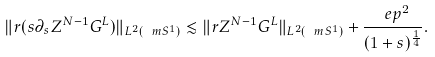<formula> <loc_0><loc_0><loc_500><loc_500>\| r ( s \partial _ { s } Z ^ { N - 1 } G ^ { L } ) \| _ { L ^ { 2 } ( \ m S ^ { 1 } ) } \lesssim \| r Z ^ { N - 1 } G ^ { L } \| _ { L ^ { 2 } ( \ m S ^ { 1 } ) } + \frac { \ e p ^ { 2 } } { ( 1 + s ) ^ { \frac { 1 } { 4 } } } .</formula> 